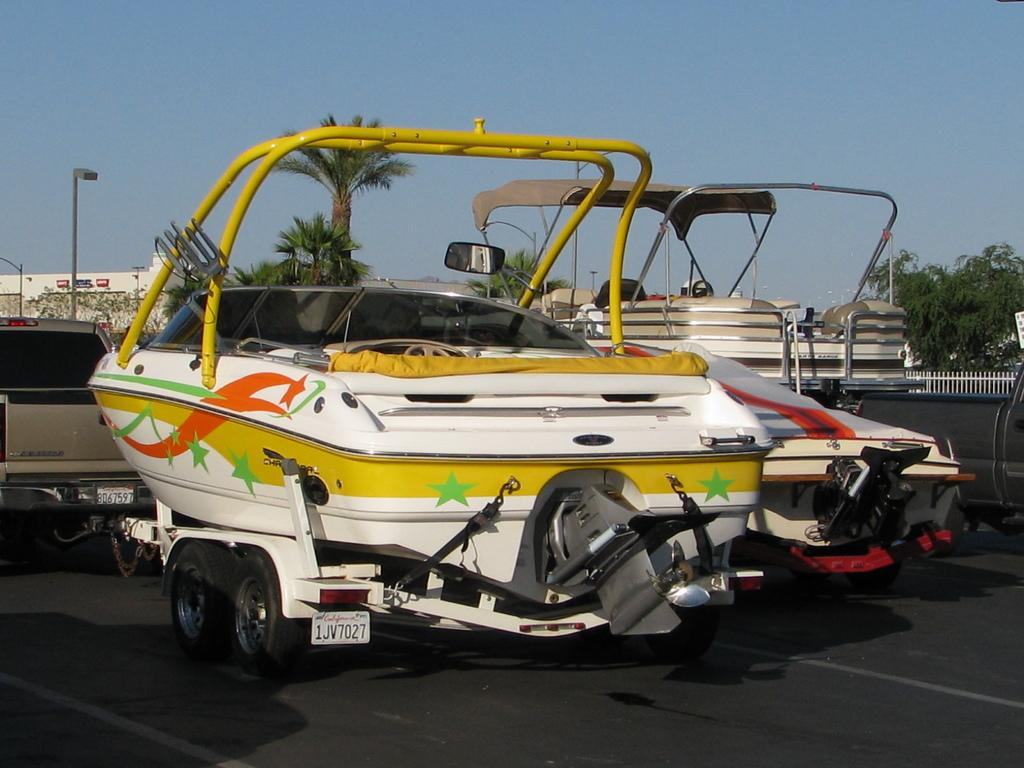What types of objects can be seen in the image? There are vehicles, trees, fencing, poles, and buildings in the image. Can you describe the landscape in the image? The image features trees and buildings, suggesting an urban or suburban setting. What type of structures are present in the image? There are fences and poles in the image, which may serve as barriers or supports. How many lawyers are visible in the image? There are no lawyers present in the image. What is the legal limit for the number of vehicles allowed in the image? There is no legal limit mentioned in the image, as it does not pertain to a specific regulation or law. 